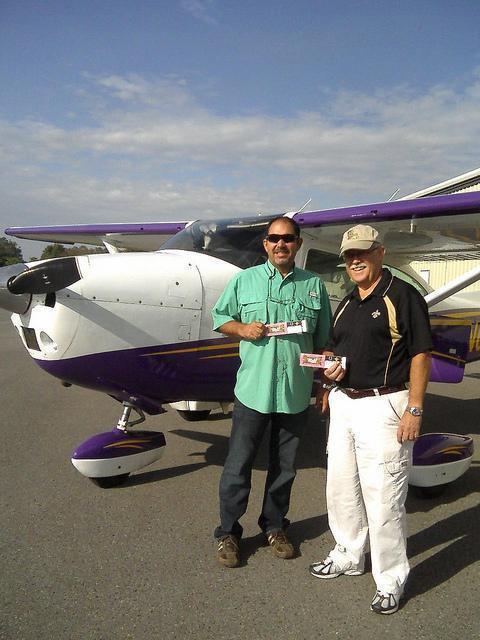What are these men displaying?
Select the accurate answer and provide explanation: 'Answer: answer
Rationale: rationale.'
Options: Pilots license, movie ticket, entrance ticket, police badge. Answer: pilots license.
Rationale: The men are standing near an airplane, not a police station, amusement park, or movie theater. the papers allow them to fly the airplane. 